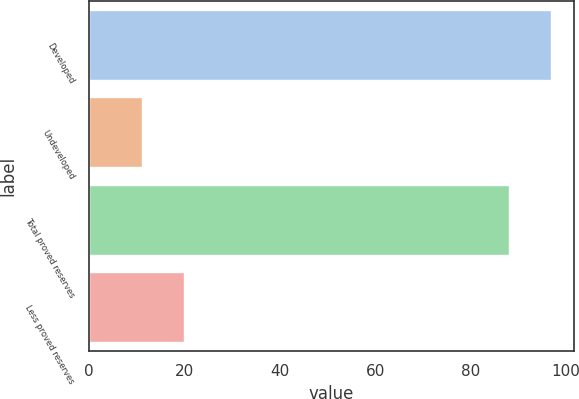Convert chart. <chart><loc_0><loc_0><loc_500><loc_500><bar_chart><fcel>Developed<fcel>Undeveloped<fcel>Total proved reserves<fcel>Less proved reserves<nl><fcel>96.9<fcel>11<fcel>88<fcel>19.9<nl></chart> 